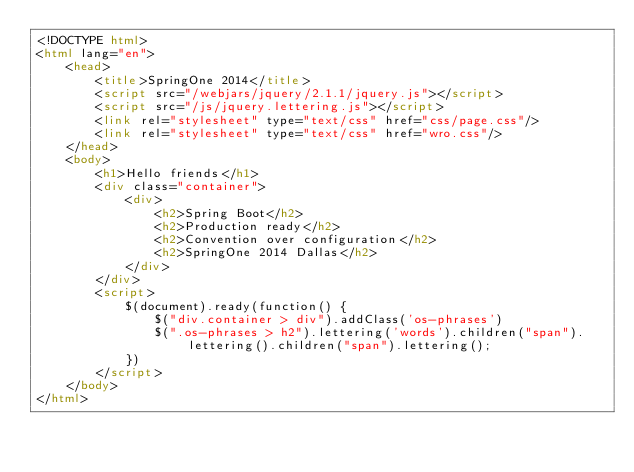<code> <loc_0><loc_0><loc_500><loc_500><_HTML_><!DOCTYPE html>
<html lang="en">
	<head>
		<title>SpringOne 2014</title>
		<script src="/webjars/jquery/2.1.1/jquery.js"></script>
		<script src="/js/jquery.lettering.js"></script>
		<link rel="stylesheet" type="text/css" href="css/page.css"/>
		<link rel="stylesheet" type="text/css" href="wro.css"/>
	</head>
	<body>
		<h1>Hello friends</h1>
		<div class="container">
			<div>
				<h2>Spring Boot</h2>
				<h2>Production ready</h2>
				<h2>Convention over configuration</h2>
				<h2>SpringOne 2014 Dallas</h2>
			</div>
		</div>
		<script>
			$(document).ready(function() {
				$("div.container > div").addClass('os-phrases')
				$(".os-phrases > h2").lettering('words').children("span").lettering().children("span").lettering();
			})
		</script>
	</body>
</html>
</code> 